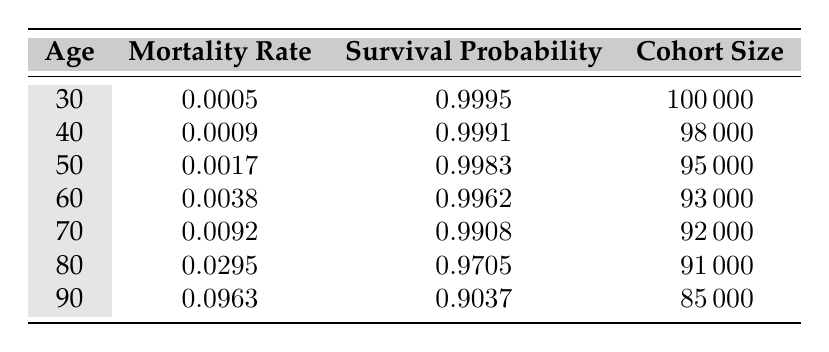What is the mortality rate for homeowners aged 50? The table shows the mortality rate for each age group. For homeowners aged 50, the mortality rate is listed directly in the table.
Answer: 0.0017 How many homeowners are there in the 60 age group? The cohort size for the 60 age group is explicitly stated in the table. By referring to that row, we can see the number of homeowners aged 60.
Answer: 93000 What is the survival probability for homeowners aged 80? The survival probability for the age group of 80 is given in the table, so we can find that value directly in the corresponding row.
Answer: 0.9705 Is the mortality rate higher for homeowners aged 70 than for those aged 60? To answer this, we compare the mortality rates for both age groups by looking at the respective rows. The mortality rate for 70 is 0.0092 and for 60 is 0.0038, thus confirming that 0.0092 is greater than 0.0038.
Answer: Yes What is the average mortality rate for homeowners aged 30, 40, and 50? First, we find the mortality rates for these three age groups: 0.0005 (30), 0.0009 (40), and 0.0017 (50). Then, we calculate the average by summing these rates: 0.0005 + 0.0009 + 0.0017 = 0.0031. Finally, we divide by the number of groups (3): 0.0031 / 3 = 0.001033.
Answer: 0.0010 For which age group is the survival probability the lowest? We need to look at the survival probabilities for each age group in the table. The lowest value is for the 90 age group, which has a survival probability of 0.9037. We can see that this is lower than all other age groups listed.
Answer: 90 What is the difference in survival probabilities between homeowners aged 40 and 80? We extract the survival probabilities from the table: 0.9991 (40) and 0.9705 (80). To find the difference, we subtract: 0.9991 - 0.9705 = 0.0286. Thus, the difference is 0.0286.
Answer: 0.0286 Are the number of homeowners aged 90 greater than those aged 80? By checking the cohort sizes in the table, we find that the cohort size for age 90 is 85000, while for age 80, it is 91000. Therefore, 85000 is less than 91000.
Answer: No What is the combined cohort size for homeowners aged 30 and 60? From the table, we get the cohort size for age 30 as 100000 and for age 60 as 93000. The combined cohort size is found by adding these two numbers together: 100000 + 93000 = 193000.
Answer: 193000 